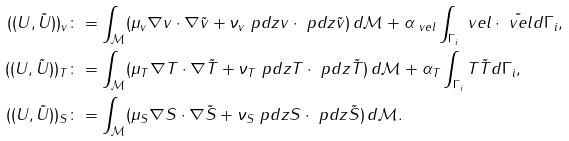<formula> <loc_0><loc_0><loc_500><loc_500>( ( U , \tilde { U } ) ) _ { v } & \colon = \int _ { \mathcal { M } } ( \mu _ { v } \nabla v \cdot \nabla \tilde { v } + \nu _ { v } \ p d { z } v \cdot \ p d { z } \tilde { v } ) \, d \mathcal { M } + \alpha _ { \ v e l } \int _ { \Gamma _ { i } } \ v e l \cdot \tilde { \ v e l } d \Gamma _ { i } , \\ ( ( U , \tilde { U } ) ) _ { T } & \colon = \int _ { \mathcal { M } } ( \mu _ { T } \nabla T \cdot \nabla \tilde { T } + \nu _ { T } \ p d { z } T \cdot \ p d { z } \tilde { T } ) \, d \mathcal { M } + \alpha _ { T } \int _ { \Gamma _ { i } } T \tilde { T } d \Gamma _ { i } , \\ ( ( U , \tilde { U } ) ) _ { S } & \colon = \int _ { \mathcal { M } } ( \mu _ { S } \nabla S \cdot \nabla \tilde { S } + \nu _ { S } \ p d { z } S \cdot \ p d { z } \tilde { S } ) \, d \mathcal { M } .</formula> 